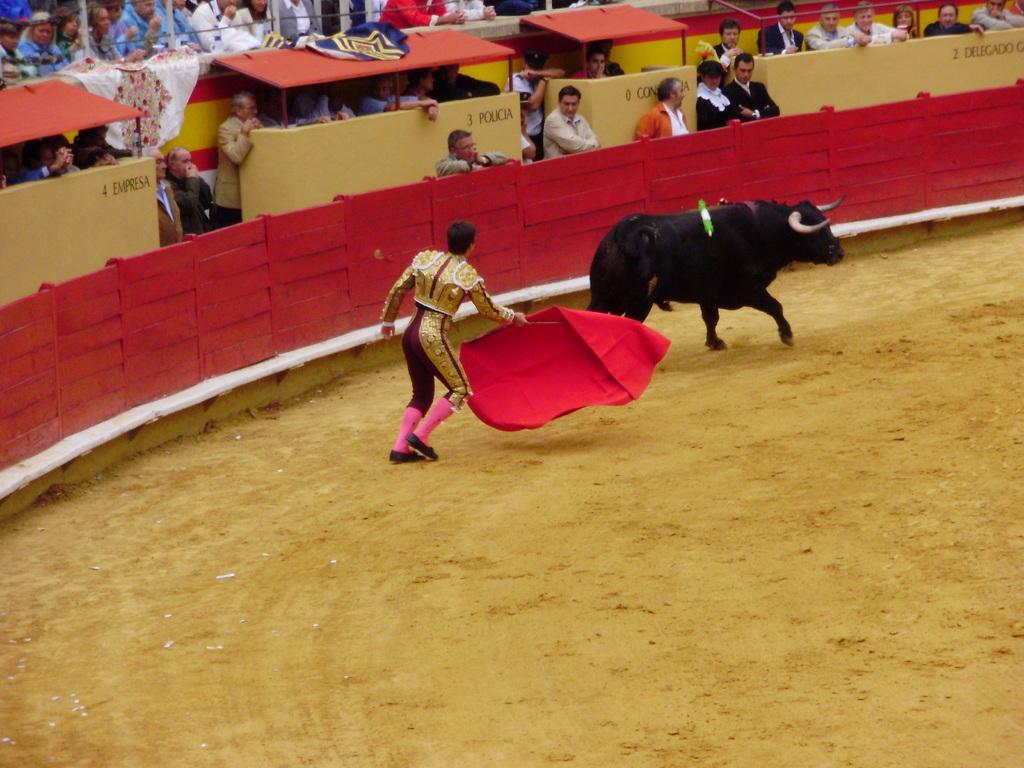Describe this image in one or two sentences. This image consists of a bull. And we can see man holding a red cloth. At the bottom, there is ground. In the background, there are many persons. In the middle, there is a fencing made up of wood. 